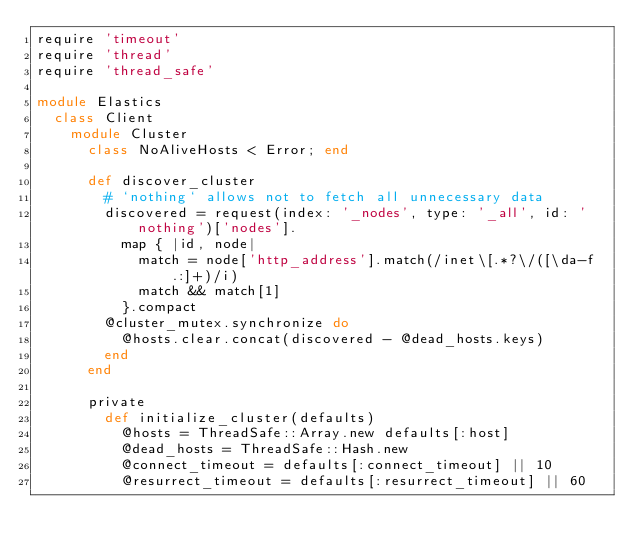Convert code to text. <code><loc_0><loc_0><loc_500><loc_500><_Ruby_>require 'timeout'
require 'thread'
require 'thread_safe'

module Elastics
  class Client
    module Cluster
      class NoAliveHosts < Error; end

      def discover_cluster
        # `nothing` allows not to fetch all unnecessary data
        discovered = request(index: '_nodes', type: '_all', id: 'nothing')['nodes'].
          map { |id, node|
            match = node['http_address'].match(/inet\[.*?\/([\da-f.:]+)/i)
            match && match[1]
          }.compact
        @cluster_mutex.synchronize do
          @hosts.clear.concat(discovered - @dead_hosts.keys)
        end
      end

      private
        def initialize_cluster(defaults)
          @hosts = ThreadSafe::Array.new defaults[:host]
          @dead_hosts = ThreadSafe::Hash.new
          @connect_timeout = defaults[:connect_timeout] || 10
          @resurrect_timeout = defaults[:resurrect_timeout] || 60</code> 